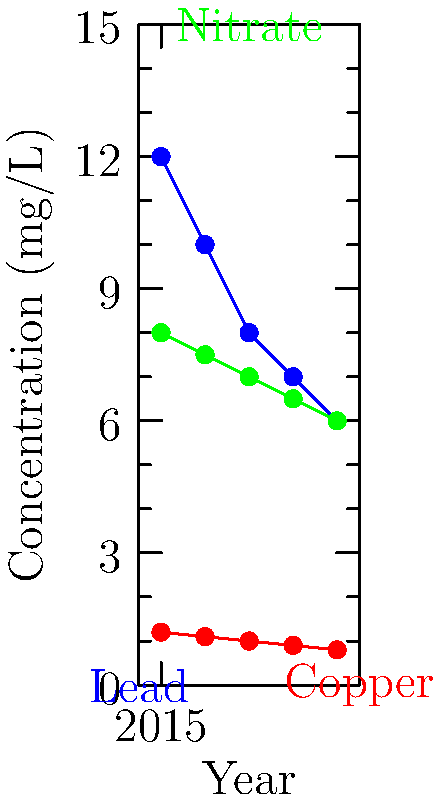Based on the water quality report graph, which contaminant has shown the most significant percentage reduction from 2015 to 2019, and what is the approximate percentage decrease? To determine which contaminant has shown the most significant percentage reduction, we need to calculate the percentage decrease for each contaminant from 2015 to 2019:

1. Lead:
   - 2015 value: 12 mg/L
   - 2019 value: 6 mg/L
   - Percentage decrease = $\frac{12 - 6}{12} \times 100\% = 50\%$

2. Copper:
   - 2015 value: 1.2 mg/L
   - 2019 value: 0.8 mg/L
   - Percentage decrease = $\frac{1.2 - 0.8}{1.2} \times 100\% \approx 33.33\%$

3. Nitrate:
   - 2015 value: 8 mg/L
   - 2019 value: 6 mg/L
   - Percentage decrease = $\frac{8 - 6}{8} \times 100\% = 25\%$

Comparing the percentage decreases:
Lead: 50%
Copper: 33.33%
Nitrate: 25%

Lead has shown the most significant percentage reduction at 50%.
Answer: Lead, 50% 